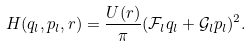<formula> <loc_0><loc_0><loc_500><loc_500>H ( q _ { l } , p _ { l } , r ) = \frac { U ( r ) } { \pi } ( \mathcal { F } _ { l } q _ { l } + \mathcal { G } _ { l } p _ { l } ) ^ { 2 } .</formula> 